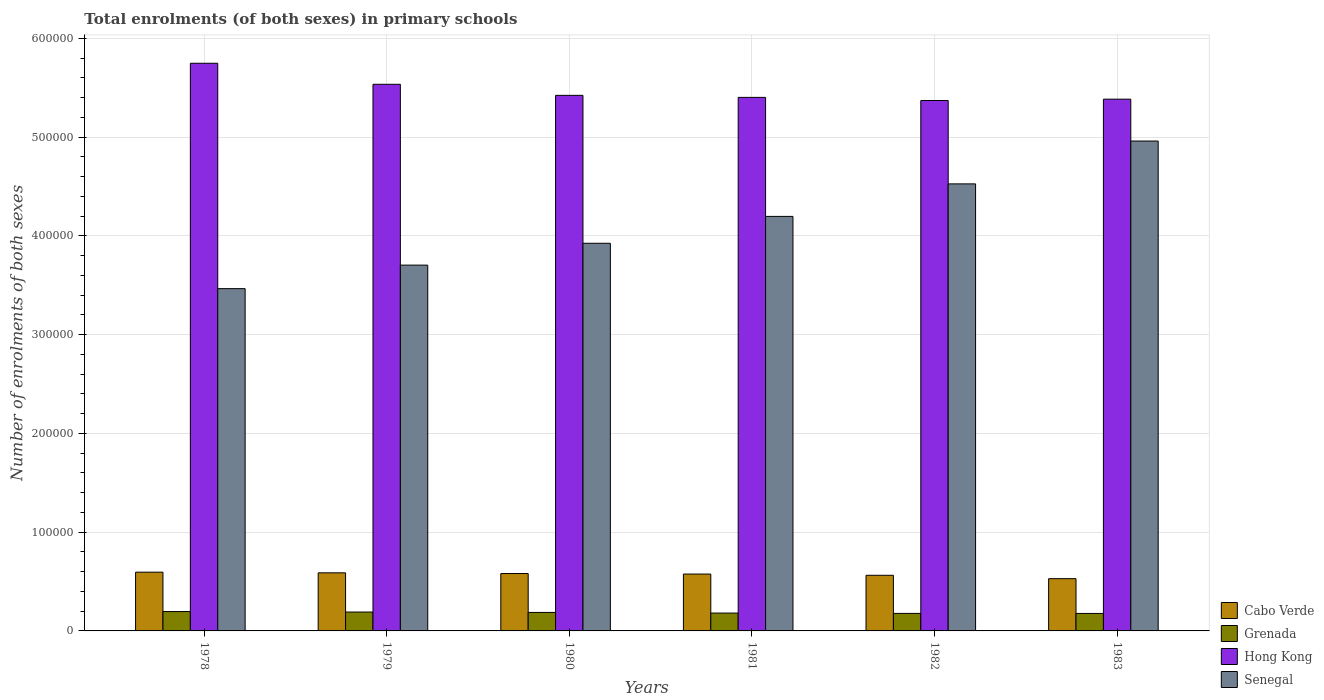How many different coloured bars are there?
Your response must be concise. 4. How many groups of bars are there?
Offer a terse response. 6. Are the number of bars per tick equal to the number of legend labels?
Offer a terse response. Yes. Are the number of bars on each tick of the X-axis equal?
Give a very brief answer. Yes. In how many cases, is the number of bars for a given year not equal to the number of legend labels?
Keep it short and to the point. 0. What is the number of enrolments in primary schools in Grenada in 1978?
Keep it short and to the point. 1.96e+04. Across all years, what is the maximum number of enrolments in primary schools in Senegal?
Make the answer very short. 4.96e+05. Across all years, what is the minimum number of enrolments in primary schools in Hong Kong?
Provide a succinct answer. 5.37e+05. In which year was the number of enrolments in primary schools in Hong Kong maximum?
Give a very brief answer. 1978. In which year was the number of enrolments in primary schools in Senegal minimum?
Ensure brevity in your answer.  1978. What is the total number of enrolments in primary schools in Senegal in the graph?
Provide a succinct answer. 2.48e+06. What is the difference between the number of enrolments in primary schools in Senegal in 1979 and that in 1983?
Offer a very short reply. -1.26e+05. What is the difference between the number of enrolments in primary schools in Cabo Verde in 1981 and the number of enrolments in primary schools in Hong Kong in 1978?
Offer a terse response. -5.17e+05. What is the average number of enrolments in primary schools in Cabo Verde per year?
Give a very brief answer. 5.72e+04. In the year 1978, what is the difference between the number of enrolments in primary schools in Hong Kong and number of enrolments in primary schools in Senegal?
Give a very brief answer. 2.28e+05. In how many years, is the number of enrolments in primary schools in Hong Kong greater than 380000?
Your response must be concise. 6. What is the ratio of the number of enrolments in primary schools in Grenada in 1978 to that in 1981?
Keep it short and to the point. 1.09. Is the number of enrolments in primary schools in Senegal in 1980 less than that in 1982?
Keep it short and to the point. Yes. What is the difference between the highest and the second highest number of enrolments in primary schools in Hong Kong?
Your response must be concise. 2.13e+04. What is the difference between the highest and the lowest number of enrolments in primary schools in Grenada?
Your answer should be compact. 1914. In how many years, is the number of enrolments in primary schools in Grenada greater than the average number of enrolments in primary schools in Grenada taken over all years?
Give a very brief answer. 3. Is the sum of the number of enrolments in primary schools in Hong Kong in 1978 and 1983 greater than the maximum number of enrolments in primary schools in Grenada across all years?
Your answer should be compact. Yes. What does the 4th bar from the left in 1980 represents?
Provide a short and direct response. Senegal. What does the 2nd bar from the right in 1983 represents?
Ensure brevity in your answer.  Hong Kong. How many years are there in the graph?
Offer a terse response. 6. What is the difference between two consecutive major ticks on the Y-axis?
Your answer should be very brief. 1.00e+05. Where does the legend appear in the graph?
Ensure brevity in your answer.  Bottom right. How are the legend labels stacked?
Offer a terse response. Vertical. What is the title of the graph?
Ensure brevity in your answer.  Total enrolments (of both sexes) in primary schools. What is the label or title of the X-axis?
Offer a very short reply. Years. What is the label or title of the Y-axis?
Make the answer very short. Number of enrolments of both sexes. What is the Number of enrolments of both sexes of Cabo Verde in 1978?
Keep it short and to the point. 5.95e+04. What is the Number of enrolments of both sexes in Grenada in 1978?
Make the answer very short. 1.96e+04. What is the Number of enrolments of both sexes of Hong Kong in 1978?
Provide a short and direct response. 5.75e+05. What is the Number of enrolments of both sexes of Senegal in 1978?
Provide a succinct answer. 3.47e+05. What is the Number of enrolments of both sexes in Cabo Verde in 1979?
Offer a very short reply. 5.88e+04. What is the Number of enrolments of both sexes in Grenada in 1979?
Provide a short and direct response. 1.91e+04. What is the Number of enrolments of both sexes of Hong Kong in 1979?
Provide a succinct answer. 5.54e+05. What is the Number of enrolments of both sexes in Senegal in 1979?
Offer a terse response. 3.70e+05. What is the Number of enrolments of both sexes in Cabo Verde in 1980?
Ensure brevity in your answer.  5.81e+04. What is the Number of enrolments of both sexes in Grenada in 1980?
Your response must be concise. 1.87e+04. What is the Number of enrolments of both sexes in Hong Kong in 1980?
Your response must be concise. 5.42e+05. What is the Number of enrolments of both sexes of Senegal in 1980?
Keep it short and to the point. 3.93e+05. What is the Number of enrolments of both sexes of Cabo Verde in 1981?
Provide a succinct answer. 5.76e+04. What is the Number of enrolments of both sexes in Grenada in 1981?
Your answer should be compact. 1.81e+04. What is the Number of enrolments of both sexes in Hong Kong in 1981?
Your answer should be very brief. 5.40e+05. What is the Number of enrolments of both sexes in Senegal in 1981?
Give a very brief answer. 4.20e+05. What is the Number of enrolments of both sexes of Cabo Verde in 1982?
Provide a short and direct response. 5.63e+04. What is the Number of enrolments of both sexes of Grenada in 1982?
Keep it short and to the point. 1.77e+04. What is the Number of enrolments of both sexes in Hong Kong in 1982?
Your answer should be very brief. 5.37e+05. What is the Number of enrolments of both sexes in Senegal in 1982?
Provide a succinct answer. 4.53e+05. What is the Number of enrolments of both sexes in Cabo Verde in 1983?
Offer a terse response. 5.29e+04. What is the Number of enrolments of both sexes of Grenada in 1983?
Your answer should be very brief. 1.77e+04. What is the Number of enrolments of both sexes of Hong Kong in 1983?
Make the answer very short. 5.38e+05. What is the Number of enrolments of both sexes in Senegal in 1983?
Give a very brief answer. 4.96e+05. Across all years, what is the maximum Number of enrolments of both sexes in Cabo Verde?
Offer a very short reply. 5.95e+04. Across all years, what is the maximum Number of enrolments of both sexes in Grenada?
Provide a succinct answer. 1.96e+04. Across all years, what is the maximum Number of enrolments of both sexes in Hong Kong?
Give a very brief answer. 5.75e+05. Across all years, what is the maximum Number of enrolments of both sexes of Senegal?
Keep it short and to the point. 4.96e+05. Across all years, what is the minimum Number of enrolments of both sexes in Cabo Verde?
Your answer should be compact. 5.29e+04. Across all years, what is the minimum Number of enrolments of both sexes of Grenada?
Give a very brief answer. 1.77e+04. Across all years, what is the minimum Number of enrolments of both sexes of Hong Kong?
Provide a short and direct response. 5.37e+05. Across all years, what is the minimum Number of enrolments of both sexes in Senegal?
Provide a short and direct response. 3.47e+05. What is the total Number of enrolments of both sexes in Cabo Verde in the graph?
Your answer should be very brief. 3.43e+05. What is the total Number of enrolments of both sexes of Grenada in the graph?
Make the answer very short. 1.11e+05. What is the total Number of enrolments of both sexes in Hong Kong in the graph?
Provide a short and direct response. 3.29e+06. What is the total Number of enrolments of both sexes of Senegal in the graph?
Offer a very short reply. 2.48e+06. What is the difference between the Number of enrolments of both sexes in Cabo Verde in 1978 and that in 1979?
Your answer should be very brief. 673. What is the difference between the Number of enrolments of both sexes of Grenada in 1978 and that in 1979?
Your answer should be very brief. 504. What is the difference between the Number of enrolments of both sexes of Hong Kong in 1978 and that in 1979?
Your answer should be very brief. 2.13e+04. What is the difference between the Number of enrolments of both sexes in Senegal in 1978 and that in 1979?
Your response must be concise. -2.38e+04. What is the difference between the Number of enrolments of both sexes in Cabo Verde in 1978 and that in 1980?
Ensure brevity in your answer.  1387. What is the difference between the Number of enrolments of both sexes of Grenada in 1978 and that in 1980?
Make the answer very short. 898. What is the difference between the Number of enrolments of both sexes of Hong Kong in 1978 and that in 1980?
Make the answer very short. 3.25e+04. What is the difference between the Number of enrolments of both sexes in Senegal in 1978 and that in 1980?
Your answer should be very brief. -4.60e+04. What is the difference between the Number of enrolments of both sexes of Cabo Verde in 1978 and that in 1981?
Provide a short and direct response. 1911. What is the difference between the Number of enrolments of both sexes in Grenada in 1978 and that in 1981?
Provide a short and direct response. 1542. What is the difference between the Number of enrolments of both sexes in Hong Kong in 1978 and that in 1981?
Ensure brevity in your answer.  3.46e+04. What is the difference between the Number of enrolments of both sexes in Senegal in 1978 and that in 1981?
Give a very brief answer. -7.32e+04. What is the difference between the Number of enrolments of both sexes in Cabo Verde in 1978 and that in 1982?
Your answer should be compact. 3166. What is the difference between the Number of enrolments of both sexes of Grenada in 1978 and that in 1982?
Your answer should be compact. 1879. What is the difference between the Number of enrolments of both sexes in Hong Kong in 1978 and that in 1982?
Keep it short and to the point. 3.77e+04. What is the difference between the Number of enrolments of both sexes of Senegal in 1978 and that in 1982?
Your answer should be compact. -1.06e+05. What is the difference between the Number of enrolments of both sexes in Cabo Verde in 1978 and that in 1983?
Offer a very short reply. 6589. What is the difference between the Number of enrolments of both sexes in Grenada in 1978 and that in 1983?
Your answer should be very brief. 1914. What is the difference between the Number of enrolments of both sexes of Hong Kong in 1978 and that in 1983?
Offer a very short reply. 3.64e+04. What is the difference between the Number of enrolments of both sexes in Senegal in 1978 and that in 1983?
Provide a short and direct response. -1.49e+05. What is the difference between the Number of enrolments of both sexes in Cabo Verde in 1979 and that in 1980?
Your answer should be compact. 714. What is the difference between the Number of enrolments of both sexes of Grenada in 1979 and that in 1980?
Offer a very short reply. 394. What is the difference between the Number of enrolments of both sexes in Hong Kong in 1979 and that in 1980?
Give a very brief answer. 1.12e+04. What is the difference between the Number of enrolments of both sexes in Senegal in 1979 and that in 1980?
Give a very brief answer. -2.21e+04. What is the difference between the Number of enrolments of both sexes of Cabo Verde in 1979 and that in 1981?
Provide a succinct answer. 1238. What is the difference between the Number of enrolments of both sexes in Grenada in 1979 and that in 1981?
Keep it short and to the point. 1038. What is the difference between the Number of enrolments of both sexes in Hong Kong in 1979 and that in 1981?
Your answer should be very brief. 1.33e+04. What is the difference between the Number of enrolments of both sexes of Senegal in 1979 and that in 1981?
Keep it short and to the point. -4.93e+04. What is the difference between the Number of enrolments of both sexes in Cabo Verde in 1979 and that in 1982?
Your answer should be compact. 2493. What is the difference between the Number of enrolments of both sexes of Grenada in 1979 and that in 1982?
Provide a succinct answer. 1375. What is the difference between the Number of enrolments of both sexes of Hong Kong in 1979 and that in 1982?
Ensure brevity in your answer.  1.64e+04. What is the difference between the Number of enrolments of both sexes in Senegal in 1979 and that in 1982?
Make the answer very short. -8.23e+04. What is the difference between the Number of enrolments of both sexes in Cabo Verde in 1979 and that in 1983?
Offer a very short reply. 5916. What is the difference between the Number of enrolments of both sexes in Grenada in 1979 and that in 1983?
Provide a succinct answer. 1410. What is the difference between the Number of enrolments of both sexes in Hong Kong in 1979 and that in 1983?
Make the answer very short. 1.51e+04. What is the difference between the Number of enrolments of both sexes in Senegal in 1979 and that in 1983?
Provide a short and direct response. -1.26e+05. What is the difference between the Number of enrolments of both sexes in Cabo Verde in 1980 and that in 1981?
Make the answer very short. 524. What is the difference between the Number of enrolments of both sexes of Grenada in 1980 and that in 1981?
Offer a very short reply. 644. What is the difference between the Number of enrolments of both sexes of Hong Kong in 1980 and that in 1981?
Ensure brevity in your answer.  2067. What is the difference between the Number of enrolments of both sexes of Senegal in 1980 and that in 1981?
Make the answer very short. -2.72e+04. What is the difference between the Number of enrolments of both sexes of Cabo Verde in 1980 and that in 1982?
Make the answer very short. 1779. What is the difference between the Number of enrolments of both sexes in Grenada in 1980 and that in 1982?
Provide a short and direct response. 981. What is the difference between the Number of enrolments of both sexes of Hong Kong in 1980 and that in 1982?
Provide a succinct answer. 5204. What is the difference between the Number of enrolments of both sexes in Senegal in 1980 and that in 1982?
Offer a terse response. -6.01e+04. What is the difference between the Number of enrolments of both sexes in Cabo Verde in 1980 and that in 1983?
Your response must be concise. 5202. What is the difference between the Number of enrolments of both sexes of Grenada in 1980 and that in 1983?
Give a very brief answer. 1016. What is the difference between the Number of enrolments of both sexes in Hong Kong in 1980 and that in 1983?
Ensure brevity in your answer.  3869. What is the difference between the Number of enrolments of both sexes of Senegal in 1980 and that in 1983?
Provide a short and direct response. -1.04e+05. What is the difference between the Number of enrolments of both sexes of Cabo Verde in 1981 and that in 1982?
Keep it short and to the point. 1255. What is the difference between the Number of enrolments of both sexes of Grenada in 1981 and that in 1982?
Offer a terse response. 337. What is the difference between the Number of enrolments of both sexes of Hong Kong in 1981 and that in 1982?
Make the answer very short. 3137. What is the difference between the Number of enrolments of both sexes of Senegal in 1981 and that in 1982?
Your response must be concise. -3.29e+04. What is the difference between the Number of enrolments of both sexes of Cabo Verde in 1981 and that in 1983?
Provide a succinct answer. 4678. What is the difference between the Number of enrolments of both sexes of Grenada in 1981 and that in 1983?
Make the answer very short. 372. What is the difference between the Number of enrolments of both sexes in Hong Kong in 1981 and that in 1983?
Your answer should be very brief. 1802. What is the difference between the Number of enrolments of both sexes of Senegal in 1981 and that in 1983?
Your answer should be compact. -7.63e+04. What is the difference between the Number of enrolments of both sexes in Cabo Verde in 1982 and that in 1983?
Offer a terse response. 3423. What is the difference between the Number of enrolments of both sexes of Grenada in 1982 and that in 1983?
Provide a succinct answer. 35. What is the difference between the Number of enrolments of both sexes of Hong Kong in 1982 and that in 1983?
Offer a terse response. -1335. What is the difference between the Number of enrolments of both sexes of Senegal in 1982 and that in 1983?
Ensure brevity in your answer.  -4.34e+04. What is the difference between the Number of enrolments of both sexes in Cabo Verde in 1978 and the Number of enrolments of both sexes in Grenada in 1979?
Your answer should be compact. 4.04e+04. What is the difference between the Number of enrolments of both sexes of Cabo Verde in 1978 and the Number of enrolments of both sexes of Hong Kong in 1979?
Offer a very short reply. -4.94e+05. What is the difference between the Number of enrolments of both sexes of Cabo Verde in 1978 and the Number of enrolments of both sexes of Senegal in 1979?
Make the answer very short. -3.11e+05. What is the difference between the Number of enrolments of both sexes in Grenada in 1978 and the Number of enrolments of both sexes in Hong Kong in 1979?
Keep it short and to the point. -5.34e+05. What is the difference between the Number of enrolments of both sexes in Grenada in 1978 and the Number of enrolments of both sexes in Senegal in 1979?
Give a very brief answer. -3.51e+05. What is the difference between the Number of enrolments of both sexes of Hong Kong in 1978 and the Number of enrolments of both sexes of Senegal in 1979?
Keep it short and to the point. 2.04e+05. What is the difference between the Number of enrolments of both sexes of Cabo Verde in 1978 and the Number of enrolments of both sexes of Grenada in 1980?
Provide a short and direct response. 4.08e+04. What is the difference between the Number of enrolments of both sexes in Cabo Verde in 1978 and the Number of enrolments of both sexes in Hong Kong in 1980?
Provide a short and direct response. -4.83e+05. What is the difference between the Number of enrolments of both sexes in Cabo Verde in 1978 and the Number of enrolments of both sexes in Senegal in 1980?
Offer a terse response. -3.33e+05. What is the difference between the Number of enrolments of both sexes of Grenada in 1978 and the Number of enrolments of both sexes of Hong Kong in 1980?
Offer a very short reply. -5.23e+05. What is the difference between the Number of enrolments of both sexes of Grenada in 1978 and the Number of enrolments of both sexes of Senegal in 1980?
Give a very brief answer. -3.73e+05. What is the difference between the Number of enrolments of both sexes in Hong Kong in 1978 and the Number of enrolments of both sexes in Senegal in 1980?
Keep it short and to the point. 1.82e+05. What is the difference between the Number of enrolments of both sexes in Cabo Verde in 1978 and the Number of enrolments of both sexes in Grenada in 1981?
Your answer should be compact. 4.14e+04. What is the difference between the Number of enrolments of both sexes in Cabo Verde in 1978 and the Number of enrolments of both sexes in Hong Kong in 1981?
Offer a very short reply. -4.81e+05. What is the difference between the Number of enrolments of both sexes in Cabo Verde in 1978 and the Number of enrolments of both sexes in Senegal in 1981?
Your answer should be very brief. -3.60e+05. What is the difference between the Number of enrolments of both sexes of Grenada in 1978 and the Number of enrolments of both sexes of Hong Kong in 1981?
Ensure brevity in your answer.  -5.21e+05. What is the difference between the Number of enrolments of both sexes in Grenada in 1978 and the Number of enrolments of both sexes in Senegal in 1981?
Give a very brief answer. -4.00e+05. What is the difference between the Number of enrolments of both sexes of Hong Kong in 1978 and the Number of enrolments of both sexes of Senegal in 1981?
Offer a very short reply. 1.55e+05. What is the difference between the Number of enrolments of both sexes in Cabo Verde in 1978 and the Number of enrolments of both sexes in Grenada in 1982?
Keep it short and to the point. 4.18e+04. What is the difference between the Number of enrolments of both sexes in Cabo Verde in 1978 and the Number of enrolments of both sexes in Hong Kong in 1982?
Give a very brief answer. -4.78e+05. What is the difference between the Number of enrolments of both sexes in Cabo Verde in 1978 and the Number of enrolments of both sexes in Senegal in 1982?
Your response must be concise. -3.93e+05. What is the difference between the Number of enrolments of both sexes of Grenada in 1978 and the Number of enrolments of both sexes of Hong Kong in 1982?
Ensure brevity in your answer.  -5.18e+05. What is the difference between the Number of enrolments of both sexes of Grenada in 1978 and the Number of enrolments of both sexes of Senegal in 1982?
Your answer should be very brief. -4.33e+05. What is the difference between the Number of enrolments of both sexes of Hong Kong in 1978 and the Number of enrolments of both sexes of Senegal in 1982?
Provide a short and direct response. 1.22e+05. What is the difference between the Number of enrolments of both sexes of Cabo Verde in 1978 and the Number of enrolments of both sexes of Grenada in 1983?
Give a very brief answer. 4.18e+04. What is the difference between the Number of enrolments of both sexes of Cabo Verde in 1978 and the Number of enrolments of both sexes of Hong Kong in 1983?
Offer a terse response. -4.79e+05. What is the difference between the Number of enrolments of both sexes of Cabo Verde in 1978 and the Number of enrolments of both sexes of Senegal in 1983?
Make the answer very short. -4.37e+05. What is the difference between the Number of enrolments of both sexes in Grenada in 1978 and the Number of enrolments of both sexes in Hong Kong in 1983?
Make the answer very short. -5.19e+05. What is the difference between the Number of enrolments of both sexes of Grenada in 1978 and the Number of enrolments of both sexes of Senegal in 1983?
Your answer should be compact. -4.76e+05. What is the difference between the Number of enrolments of both sexes of Hong Kong in 1978 and the Number of enrolments of both sexes of Senegal in 1983?
Provide a short and direct response. 7.88e+04. What is the difference between the Number of enrolments of both sexes in Cabo Verde in 1979 and the Number of enrolments of both sexes in Grenada in 1980?
Provide a short and direct response. 4.01e+04. What is the difference between the Number of enrolments of both sexes in Cabo Verde in 1979 and the Number of enrolments of both sexes in Hong Kong in 1980?
Your response must be concise. -4.84e+05. What is the difference between the Number of enrolments of both sexes of Cabo Verde in 1979 and the Number of enrolments of both sexes of Senegal in 1980?
Give a very brief answer. -3.34e+05. What is the difference between the Number of enrolments of both sexes of Grenada in 1979 and the Number of enrolments of both sexes of Hong Kong in 1980?
Offer a very short reply. -5.23e+05. What is the difference between the Number of enrolments of both sexes of Grenada in 1979 and the Number of enrolments of both sexes of Senegal in 1980?
Ensure brevity in your answer.  -3.73e+05. What is the difference between the Number of enrolments of both sexes of Hong Kong in 1979 and the Number of enrolments of both sexes of Senegal in 1980?
Offer a very short reply. 1.61e+05. What is the difference between the Number of enrolments of both sexes in Cabo Verde in 1979 and the Number of enrolments of both sexes in Grenada in 1981?
Your response must be concise. 4.07e+04. What is the difference between the Number of enrolments of both sexes in Cabo Verde in 1979 and the Number of enrolments of both sexes in Hong Kong in 1981?
Your response must be concise. -4.81e+05. What is the difference between the Number of enrolments of both sexes in Cabo Verde in 1979 and the Number of enrolments of both sexes in Senegal in 1981?
Provide a short and direct response. -3.61e+05. What is the difference between the Number of enrolments of both sexes of Grenada in 1979 and the Number of enrolments of both sexes of Hong Kong in 1981?
Provide a succinct answer. -5.21e+05. What is the difference between the Number of enrolments of both sexes in Grenada in 1979 and the Number of enrolments of both sexes in Senegal in 1981?
Provide a succinct answer. -4.01e+05. What is the difference between the Number of enrolments of both sexes in Hong Kong in 1979 and the Number of enrolments of both sexes in Senegal in 1981?
Give a very brief answer. 1.34e+05. What is the difference between the Number of enrolments of both sexes of Cabo Verde in 1979 and the Number of enrolments of both sexes of Grenada in 1982?
Provide a succinct answer. 4.11e+04. What is the difference between the Number of enrolments of both sexes in Cabo Verde in 1979 and the Number of enrolments of both sexes in Hong Kong in 1982?
Make the answer very short. -4.78e+05. What is the difference between the Number of enrolments of both sexes in Cabo Verde in 1979 and the Number of enrolments of both sexes in Senegal in 1982?
Your answer should be very brief. -3.94e+05. What is the difference between the Number of enrolments of both sexes of Grenada in 1979 and the Number of enrolments of both sexes of Hong Kong in 1982?
Keep it short and to the point. -5.18e+05. What is the difference between the Number of enrolments of both sexes of Grenada in 1979 and the Number of enrolments of both sexes of Senegal in 1982?
Provide a succinct answer. -4.34e+05. What is the difference between the Number of enrolments of both sexes in Hong Kong in 1979 and the Number of enrolments of both sexes in Senegal in 1982?
Offer a very short reply. 1.01e+05. What is the difference between the Number of enrolments of both sexes in Cabo Verde in 1979 and the Number of enrolments of both sexes in Grenada in 1983?
Ensure brevity in your answer.  4.11e+04. What is the difference between the Number of enrolments of both sexes in Cabo Verde in 1979 and the Number of enrolments of both sexes in Hong Kong in 1983?
Provide a succinct answer. -4.80e+05. What is the difference between the Number of enrolments of both sexes in Cabo Verde in 1979 and the Number of enrolments of both sexes in Senegal in 1983?
Make the answer very short. -4.37e+05. What is the difference between the Number of enrolments of both sexes in Grenada in 1979 and the Number of enrolments of both sexes in Hong Kong in 1983?
Your answer should be very brief. -5.19e+05. What is the difference between the Number of enrolments of both sexes of Grenada in 1979 and the Number of enrolments of both sexes of Senegal in 1983?
Ensure brevity in your answer.  -4.77e+05. What is the difference between the Number of enrolments of both sexes of Hong Kong in 1979 and the Number of enrolments of both sexes of Senegal in 1983?
Ensure brevity in your answer.  5.75e+04. What is the difference between the Number of enrolments of both sexes in Cabo Verde in 1980 and the Number of enrolments of both sexes in Grenada in 1981?
Ensure brevity in your answer.  4.00e+04. What is the difference between the Number of enrolments of both sexes in Cabo Verde in 1980 and the Number of enrolments of both sexes in Hong Kong in 1981?
Your response must be concise. -4.82e+05. What is the difference between the Number of enrolments of both sexes in Cabo Verde in 1980 and the Number of enrolments of both sexes in Senegal in 1981?
Offer a very short reply. -3.62e+05. What is the difference between the Number of enrolments of both sexes of Grenada in 1980 and the Number of enrolments of both sexes of Hong Kong in 1981?
Ensure brevity in your answer.  -5.22e+05. What is the difference between the Number of enrolments of both sexes of Grenada in 1980 and the Number of enrolments of both sexes of Senegal in 1981?
Make the answer very short. -4.01e+05. What is the difference between the Number of enrolments of both sexes of Hong Kong in 1980 and the Number of enrolments of both sexes of Senegal in 1981?
Offer a terse response. 1.23e+05. What is the difference between the Number of enrolments of both sexes in Cabo Verde in 1980 and the Number of enrolments of both sexes in Grenada in 1982?
Make the answer very short. 4.04e+04. What is the difference between the Number of enrolments of both sexes in Cabo Verde in 1980 and the Number of enrolments of both sexes in Hong Kong in 1982?
Make the answer very short. -4.79e+05. What is the difference between the Number of enrolments of both sexes of Cabo Verde in 1980 and the Number of enrolments of both sexes of Senegal in 1982?
Offer a terse response. -3.95e+05. What is the difference between the Number of enrolments of both sexes in Grenada in 1980 and the Number of enrolments of both sexes in Hong Kong in 1982?
Your answer should be compact. -5.18e+05. What is the difference between the Number of enrolments of both sexes of Grenada in 1980 and the Number of enrolments of both sexes of Senegal in 1982?
Keep it short and to the point. -4.34e+05. What is the difference between the Number of enrolments of both sexes in Hong Kong in 1980 and the Number of enrolments of both sexes in Senegal in 1982?
Offer a very short reply. 8.96e+04. What is the difference between the Number of enrolments of both sexes of Cabo Verde in 1980 and the Number of enrolments of both sexes of Grenada in 1983?
Give a very brief answer. 4.04e+04. What is the difference between the Number of enrolments of both sexes in Cabo Verde in 1980 and the Number of enrolments of both sexes in Hong Kong in 1983?
Provide a succinct answer. -4.80e+05. What is the difference between the Number of enrolments of both sexes in Cabo Verde in 1980 and the Number of enrolments of both sexes in Senegal in 1983?
Your response must be concise. -4.38e+05. What is the difference between the Number of enrolments of both sexes in Grenada in 1980 and the Number of enrolments of both sexes in Hong Kong in 1983?
Your response must be concise. -5.20e+05. What is the difference between the Number of enrolments of both sexes in Grenada in 1980 and the Number of enrolments of both sexes in Senegal in 1983?
Give a very brief answer. -4.77e+05. What is the difference between the Number of enrolments of both sexes of Hong Kong in 1980 and the Number of enrolments of both sexes of Senegal in 1983?
Offer a very short reply. 4.63e+04. What is the difference between the Number of enrolments of both sexes in Cabo Verde in 1981 and the Number of enrolments of both sexes in Grenada in 1982?
Ensure brevity in your answer.  3.98e+04. What is the difference between the Number of enrolments of both sexes of Cabo Verde in 1981 and the Number of enrolments of both sexes of Hong Kong in 1982?
Offer a very short reply. -4.80e+05. What is the difference between the Number of enrolments of both sexes of Cabo Verde in 1981 and the Number of enrolments of both sexes of Senegal in 1982?
Offer a very short reply. -3.95e+05. What is the difference between the Number of enrolments of both sexes of Grenada in 1981 and the Number of enrolments of both sexes of Hong Kong in 1982?
Make the answer very short. -5.19e+05. What is the difference between the Number of enrolments of both sexes of Grenada in 1981 and the Number of enrolments of both sexes of Senegal in 1982?
Give a very brief answer. -4.35e+05. What is the difference between the Number of enrolments of both sexes in Hong Kong in 1981 and the Number of enrolments of both sexes in Senegal in 1982?
Keep it short and to the point. 8.76e+04. What is the difference between the Number of enrolments of both sexes of Cabo Verde in 1981 and the Number of enrolments of both sexes of Grenada in 1983?
Offer a terse response. 3.99e+04. What is the difference between the Number of enrolments of both sexes of Cabo Verde in 1981 and the Number of enrolments of both sexes of Hong Kong in 1983?
Keep it short and to the point. -4.81e+05. What is the difference between the Number of enrolments of both sexes in Cabo Verde in 1981 and the Number of enrolments of both sexes in Senegal in 1983?
Provide a succinct answer. -4.38e+05. What is the difference between the Number of enrolments of both sexes in Grenada in 1981 and the Number of enrolments of both sexes in Hong Kong in 1983?
Keep it short and to the point. -5.20e+05. What is the difference between the Number of enrolments of both sexes of Grenada in 1981 and the Number of enrolments of both sexes of Senegal in 1983?
Give a very brief answer. -4.78e+05. What is the difference between the Number of enrolments of both sexes in Hong Kong in 1981 and the Number of enrolments of both sexes in Senegal in 1983?
Keep it short and to the point. 4.42e+04. What is the difference between the Number of enrolments of both sexes in Cabo Verde in 1982 and the Number of enrolments of both sexes in Grenada in 1983?
Provide a short and direct response. 3.86e+04. What is the difference between the Number of enrolments of both sexes of Cabo Verde in 1982 and the Number of enrolments of both sexes of Hong Kong in 1983?
Keep it short and to the point. -4.82e+05. What is the difference between the Number of enrolments of both sexes in Cabo Verde in 1982 and the Number of enrolments of both sexes in Senegal in 1983?
Your answer should be compact. -4.40e+05. What is the difference between the Number of enrolments of both sexes of Grenada in 1982 and the Number of enrolments of both sexes of Hong Kong in 1983?
Offer a very short reply. -5.21e+05. What is the difference between the Number of enrolments of both sexes in Grenada in 1982 and the Number of enrolments of both sexes in Senegal in 1983?
Provide a succinct answer. -4.78e+05. What is the difference between the Number of enrolments of both sexes in Hong Kong in 1982 and the Number of enrolments of both sexes in Senegal in 1983?
Offer a very short reply. 4.11e+04. What is the average Number of enrolments of both sexes in Cabo Verde per year?
Give a very brief answer. 5.72e+04. What is the average Number of enrolments of both sexes of Grenada per year?
Offer a very short reply. 1.85e+04. What is the average Number of enrolments of both sexes in Hong Kong per year?
Keep it short and to the point. 5.48e+05. What is the average Number of enrolments of both sexes of Senegal per year?
Offer a very short reply. 4.13e+05. In the year 1978, what is the difference between the Number of enrolments of both sexes in Cabo Verde and Number of enrolments of both sexes in Grenada?
Provide a short and direct response. 3.99e+04. In the year 1978, what is the difference between the Number of enrolments of both sexes in Cabo Verde and Number of enrolments of both sexes in Hong Kong?
Make the answer very short. -5.15e+05. In the year 1978, what is the difference between the Number of enrolments of both sexes of Cabo Verde and Number of enrolments of both sexes of Senegal?
Ensure brevity in your answer.  -2.87e+05. In the year 1978, what is the difference between the Number of enrolments of both sexes of Grenada and Number of enrolments of both sexes of Hong Kong?
Give a very brief answer. -5.55e+05. In the year 1978, what is the difference between the Number of enrolments of both sexes of Grenada and Number of enrolments of both sexes of Senegal?
Provide a succinct answer. -3.27e+05. In the year 1978, what is the difference between the Number of enrolments of both sexes of Hong Kong and Number of enrolments of both sexes of Senegal?
Provide a short and direct response. 2.28e+05. In the year 1979, what is the difference between the Number of enrolments of both sexes of Cabo Verde and Number of enrolments of both sexes of Grenada?
Offer a terse response. 3.97e+04. In the year 1979, what is the difference between the Number of enrolments of both sexes in Cabo Verde and Number of enrolments of both sexes in Hong Kong?
Give a very brief answer. -4.95e+05. In the year 1979, what is the difference between the Number of enrolments of both sexes in Cabo Verde and Number of enrolments of both sexes in Senegal?
Your answer should be compact. -3.12e+05. In the year 1979, what is the difference between the Number of enrolments of both sexes in Grenada and Number of enrolments of both sexes in Hong Kong?
Offer a very short reply. -5.34e+05. In the year 1979, what is the difference between the Number of enrolments of both sexes in Grenada and Number of enrolments of both sexes in Senegal?
Provide a succinct answer. -3.51e+05. In the year 1979, what is the difference between the Number of enrolments of both sexes in Hong Kong and Number of enrolments of both sexes in Senegal?
Your response must be concise. 1.83e+05. In the year 1980, what is the difference between the Number of enrolments of both sexes of Cabo Verde and Number of enrolments of both sexes of Grenada?
Your response must be concise. 3.94e+04. In the year 1980, what is the difference between the Number of enrolments of both sexes in Cabo Verde and Number of enrolments of both sexes in Hong Kong?
Your answer should be compact. -4.84e+05. In the year 1980, what is the difference between the Number of enrolments of both sexes of Cabo Verde and Number of enrolments of both sexes of Senegal?
Your answer should be compact. -3.34e+05. In the year 1980, what is the difference between the Number of enrolments of both sexes in Grenada and Number of enrolments of both sexes in Hong Kong?
Offer a terse response. -5.24e+05. In the year 1980, what is the difference between the Number of enrolments of both sexes in Grenada and Number of enrolments of both sexes in Senegal?
Your response must be concise. -3.74e+05. In the year 1980, what is the difference between the Number of enrolments of both sexes in Hong Kong and Number of enrolments of both sexes in Senegal?
Provide a succinct answer. 1.50e+05. In the year 1981, what is the difference between the Number of enrolments of both sexes in Cabo Verde and Number of enrolments of both sexes in Grenada?
Your response must be concise. 3.95e+04. In the year 1981, what is the difference between the Number of enrolments of both sexes in Cabo Verde and Number of enrolments of both sexes in Hong Kong?
Offer a terse response. -4.83e+05. In the year 1981, what is the difference between the Number of enrolments of both sexes in Cabo Verde and Number of enrolments of both sexes in Senegal?
Your answer should be compact. -3.62e+05. In the year 1981, what is the difference between the Number of enrolments of both sexes of Grenada and Number of enrolments of both sexes of Hong Kong?
Your answer should be compact. -5.22e+05. In the year 1981, what is the difference between the Number of enrolments of both sexes in Grenada and Number of enrolments of both sexes in Senegal?
Offer a terse response. -4.02e+05. In the year 1981, what is the difference between the Number of enrolments of both sexes of Hong Kong and Number of enrolments of both sexes of Senegal?
Your answer should be very brief. 1.21e+05. In the year 1982, what is the difference between the Number of enrolments of both sexes in Cabo Verde and Number of enrolments of both sexes in Grenada?
Provide a short and direct response. 3.86e+04. In the year 1982, what is the difference between the Number of enrolments of both sexes of Cabo Verde and Number of enrolments of both sexes of Hong Kong?
Ensure brevity in your answer.  -4.81e+05. In the year 1982, what is the difference between the Number of enrolments of both sexes of Cabo Verde and Number of enrolments of both sexes of Senegal?
Provide a succinct answer. -3.96e+05. In the year 1982, what is the difference between the Number of enrolments of both sexes in Grenada and Number of enrolments of both sexes in Hong Kong?
Give a very brief answer. -5.19e+05. In the year 1982, what is the difference between the Number of enrolments of both sexes of Grenada and Number of enrolments of both sexes of Senegal?
Your response must be concise. -4.35e+05. In the year 1982, what is the difference between the Number of enrolments of both sexes of Hong Kong and Number of enrolments of both sexes of Senegal?
Your answer should be compact. 8.44e+04. In the year 1983, what is the difference between the Number of enrolments of both sexes of Cabo Verde and Number of enrolments of both sexes of Grenada?
Keep it short and to the point. 3.52e+04. In the year 1983, what is the difference between the Number of enrolments of both sexes in Cabo Verde and Number of enrolments of both sexes in Hong Kong?
Ensure brevity in your answer.  -4.86e+05. In the year 1983, what is the difference between the Number of enrolments of both sexes of Cabo Verde and Number of enrolments of both sexes of Senegal?
Your response must be concise. -4.43e+05. In the year 1983, what is the difference between the Number of enrolments of both sexes of Grenada and Number of enrolments of both sexes of Hong Kong?
Keep it short and to the point. -5.21e+05. In the year 1983, what is the difference between the Number of enrolments of both sexes of Grenada and Number of enrolments of both sexes of Senegal?
Keep it short and to the point. -4.78e+05. In the year 1983, what is the difference between the Number of enrolments of both sexes in Hong Kong and Number of enrolments of both sexes in Senegal?
Make the answer very short. 4.24e+04. What is the ratio of the Number of enrolments of both sexes in Cabo Verde in 1978 to that in 1979?
Your answer should be compact. 1.01. What is the ratio of the Number of enrolments of both sexes of Grenada in 1978 to that in 1979?
Your answer should be very brief. 1.03. What is the ratio of the Number of enrolments of both sexes in Hong Kong in 1978 to that in 1979?
Your answer should be very brief. 1.04. What is the ratio of the Number of enrolments of both sexes of Senegal in 1978 to that in 1979?
Your answer should be compact. 0.94. What is the ratio of the Number of enrolments of both sexes of Cabo Verde in 1978 to that in 1980?
Offer a terse response. 1.02. What is the ratio of the Number of enrolments of both sexes in Grenada in 1978 to that in 1980?
Make the answer very short. 1.05. What is the ratio of the Number of enrolments of both sexes of Hong Kong in 1978 to that in 1980?
Your response must be concise. 1.06. What is the ratio of the Number of enrolments of both sexes of Senegal in 1978 to that in 1980?
Offer a terse response. 0.88. What is the ratio of the Number of enrolments of both sexes of Cabo Verde in 1978 to that in 1981?
Your answer should be compact. 1.03. What is the ratio of the Number of enrolments of both sexes in Grenada in 1978 to that in 1981?
Your answer should be compact. 1.09. What is the ratio of the Number of enrolments of both sexes of Hong Kong in 1978 to that in 1981?
Your answer should be compact. 1.06. What is the ratio of the Number of enrolments of both sexes of Senegal in 1978 to that in 1981?
Ensure brevity in your answer.  0.83. What is the ratio of the Number of enrolments of both sexes of Cabo Verde in 1978 to that in 1982?
Your response must be concise. 1.06. What is the ratio of the Number of enrolments of both sexes in Grenada in 1978 to that in 1982?
Your answer should be very brief. 1.11. What is the ratio of the Number of enrolments of both sexes of Hong Kong in 1978 to that in 1982?
Ensure brevity in your answer.  1.07. What is the ratio of the Number of enrolments of both sexes in Senegal in 1978 to that in 1982?
Give a very brief answer. 0.77. What is the ratio of the Number of enrolments of both sexes in Cabo Verde in 1978 to that in 1983?
Provide a succinct answer. 1.12. What is the ratio of the Number of enrolments of both sexes of Grenada in 1978 to that in 1983?
Provide a short and direct response. 1.11. What is the ratio of the Number of enrolments of both sexes of Hong Kong in 1978 to that in 1983?
Make the answer very short. 1.07. What is the ratio of the Number of enrolments of both sexes in Senegal in 1978 to that in 1983?
Provide a succinct answer. 0.7. What is the ratio of the Number of enrolments of both sexes in Cabo Verde in 1979 to that in 1980?
Ensure brevity in your answer.  1.01. What is the ratio of the Number of enrolments of both sexes in Hong Kong in 1979 to that in 1980?
Make the answer very short. 1.02. What is the ratio of the Number of enrolments of both sexes of Senegal in 1979 to that in 1980?
Offer a very short reply. 0.94. What is the ratio of the Number of enrolments of both sexes in Cabo Verde in 1979 to that in 1981?
Make the answer very short. 1.02. What is the ratio of the Number of enrolments of both sexes in Grenada in 1979 to that in 1981?
Your answer should be compact. 1.06. What is the ratio of the Number of enrolments of both sexes in Hong Kong in 1979 to that in 1981?
Ensure brevity in your answer.  1.02. What is the ratio of the Number of enrolments of both sexes of Senegal in 1979 to that in 1981?
Keep it short and to the point. 0.88. What is the ratio of the Number of enrolments of both sexes in Cabo Verde in 1979 to that in 1982?
Your answer should be compact. 1.04. What is the ratio of the Number of enrolments of both sexes in Grenada in 1979 to that in 1982?
Provide a succinct answer. 1.08. What is the ratio of the Number of enrolments of both sexes in Hong Kong in 1979 to that in 1982?
Provide a short and direct response. 1.03. What is the ratio of the Number of enrolments of both sexes of Senegal in 1979 to that in 1982?
Make the answer very short. 0.82. What is the ratio of the Number of enrolments of both sexes of Cabo Verde in 1979 to that in 1983?
Provide a succinct answer. 1.11. What is the ratio of the Number of enrolments of both sexes of Grenada in 1979 to that in 1983?
Provide a short and direct response. 1.08. What is the ratio of the Number of enrolments of both sexes in Hong Kong in 1979 to that in 1983?
Your answer should be compact. 1.03. What is the ratio of the Number of enrolments of both sexes of Senegal in 1979 to that in 1983?
Ensure brevity in your answer.  0.75. What is the ratio of the Number of enrolments of both sexes in Cabo Verde in 1980 to that in 1981?
Offer a very short reply. 1.01. What is the ratio of the Number of enrolments of both sexes of Grenada in 1980 to that in 1981?
Provide a short and direct response. 1.04. What is the ratio of the Number of enrolments of both sexes in Hong Kong in 1980 to that in 1981?
Offer a terse response. 1. What is the ratio of the Number of enrolments of both sexes of Senegal in 1980 to that in 1981?
Your response must be concise. 0.94. What is the ratio of the Number of enrolments of both sexes of Cabo Verde in 1980 to that in 1982?
Ensure brevity in your answer.  1.03. What is the ratio of the Number of enrolments of both sexes of Grenada in 1980 to that in 1982?
Give a very brief answer. 1.06. What is the ratio of the Number of enrolments of both sexes of Hong Kong in 1980 to that in 1982?
Your response must be concise. 1.01. What is the ratio of the Number of enrolments of both sexes of Senegal in 1980 to that in 1982?
Your answer should be compact. 0.87. What is the ratio of the Number of enrolments of both sexes of Cabo Verde in 1980 to that in 1983?
Your response must be concise. 1.1. What is the ratio of the Number of enrolments of both sexes of Grenada in 1980 to that in 1983?
Keep it short and to the point. 1.06. What is the ratio of the Number of enrolments of both sexes in Senegal in 1980 to that in 1983?
Give a very brief answer. 0.79. What is the ratio of the Number of enrolments of both sexes of Cabo Verde in 1981 to that in 1982?
Your answer should be compact. 1.02. What is the ratio of the Number of enrolments of both sexes in Grenada in 1981 to that in 1982?
Offer a terse response. 1.02. What is the ratio of the Number of enrolments of both sexes in Hong Kong in 1981 to that in 1982?
Offer a terse response. 1.01. What is the ratio of the Number of enrolments of both sexes in Senegal in 1981 to that in 1982?
Provide a succinct answer. 0.93. What is the ratio of the Number of enrolments of both sexes in Cabo Verde in 1981 to that in 1983?
Your answer should be compact. 1.09. What is the ratio of the Number of enrolments of both sexes of Grenada in 1981 to that in 1983?
Make the answer very short. 1.02. What is the ratio of the Number of enrolments of both sexes of Hong Kong in 1981 to that in 1983?
Offer a very short reply. 1. What is the ratio of the Number of enrolments of both sexes in Senegal in 1981 to that in 1983?
Offer a terse response. 0.85. What is the ratio of the Number of enrolments of both sexes of Cabo Verde in 1982 to that in 1983?
Provide a short and direct response. 1.06. What is the ratio of the Number of enrolments of both sexes of Grenada in 1982 to that in 1983?
Ensure brevity in your answer.  1. What is the ratio of the Number of enrolments of both sexes of Hong Kong in 1982 to that in 1983?
Provide a succinct answer. 1. What is the ratio of the Number of enrolments of both sexes of Senegal in 1982 to that in 1983?
Keep it short and to the point. 0.91. What is the difference between the highest and the second highest Number of enrolments of both sexes of Cabo Verde?
Your response must be concise. 673. What is the difference between the highest and the second highest Number of enrolments of both sexes of Grenada?
Give a very brief answer. 504. What is the difference between the highest and the second highest Number of enrolments of both sexes in Hong Kong?
Ensure brevity in your answer.  2.13e+04. What is the difference between the highest and the second highest Number of enrolments of both sexes in Senegal?
Ensure brevity in your answer.  4.34e+04. What is the difference between the highest and the lowest Number of enrolments of both sexes in Cabo Verde?
Ensure brevity in your answer.  6589. What is the difference between the highest and the lowest Number of enrolments of both sexes of Grenada?
Your answer should be very brief. 1914. What is the difference between the highest and the lowest Number of enrolments of both sexes in Hong Kong?
Your answer should be very brief. 3.77e+04. What is the difference between the highest and the lowest Number of enrolments of both sexes of Senegal?
Your response must be concise. 1.49e+05. 